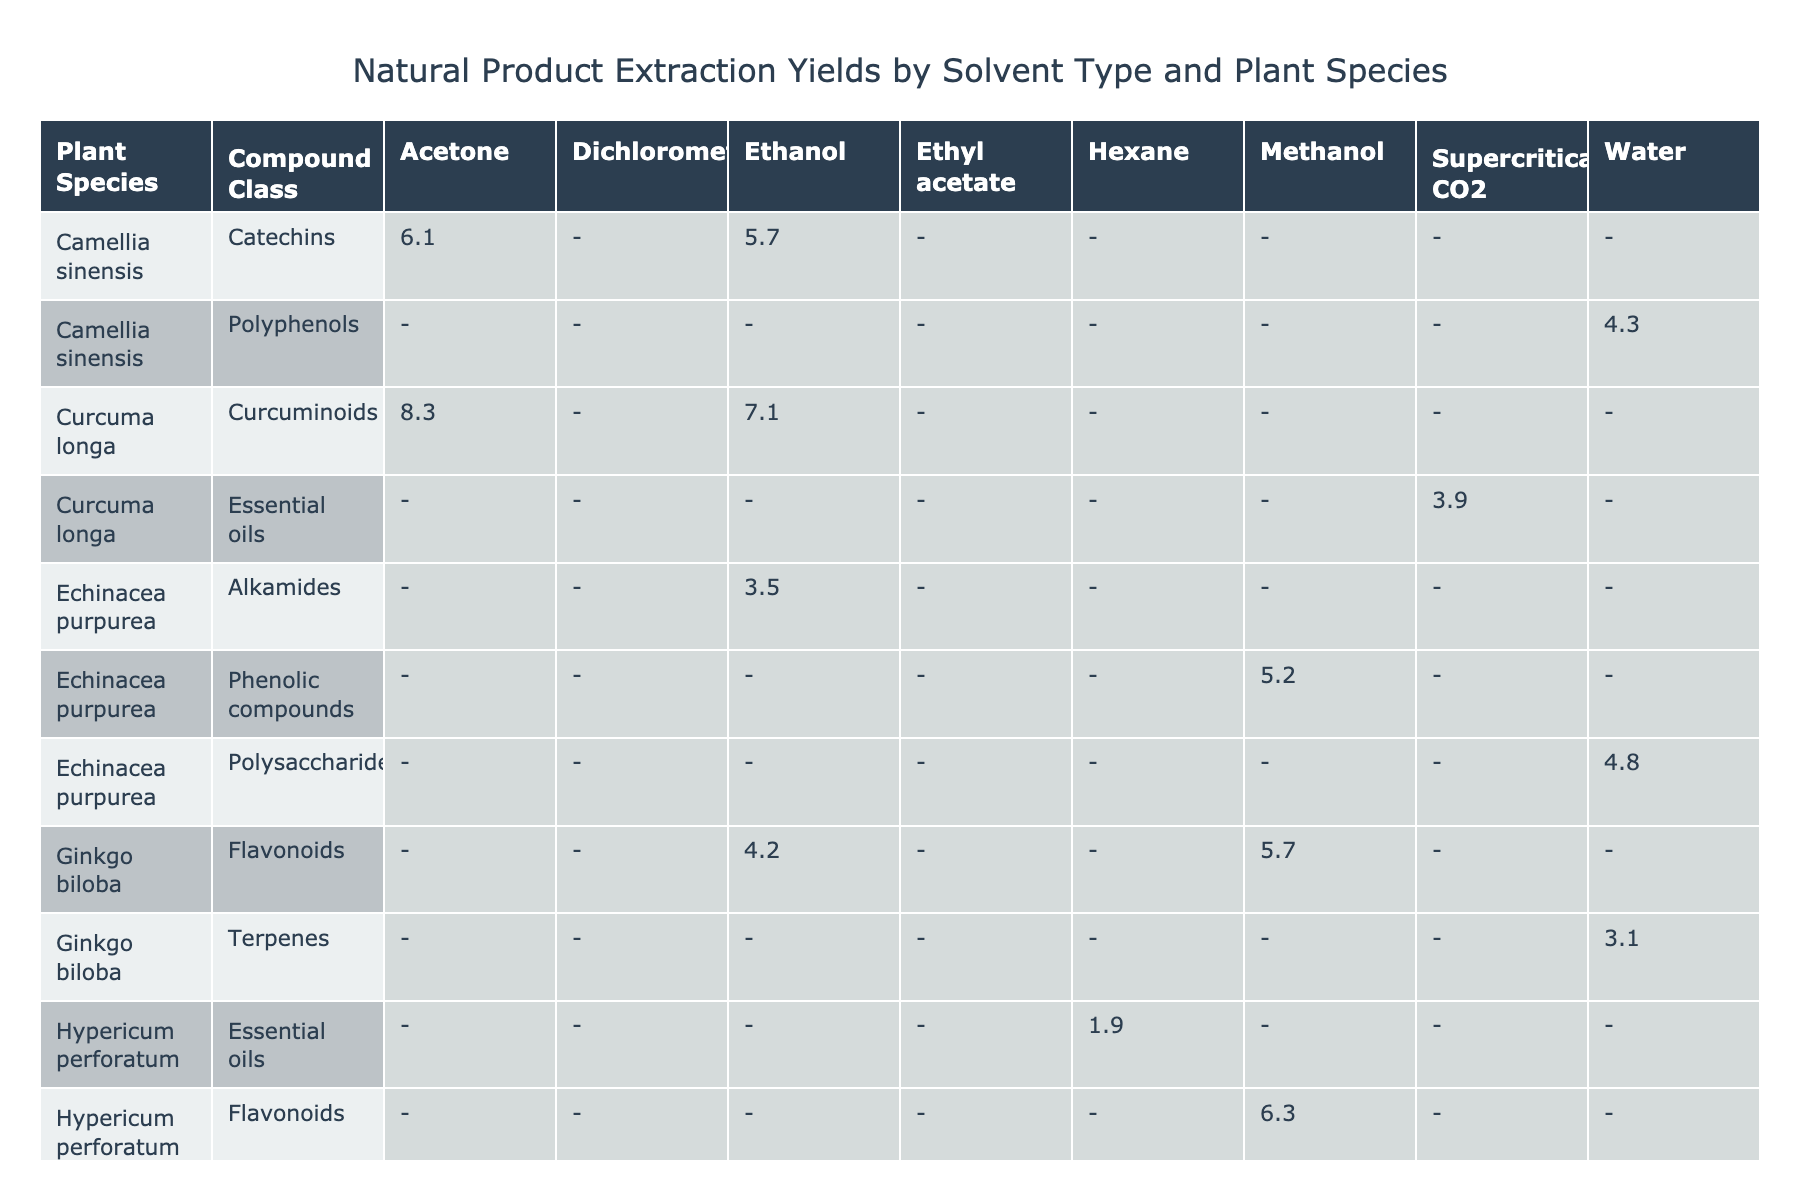What is the highest yield obtained for Ginkgo biloba? In the table, looking at the yield values for Ginkgo biloba, the percentage yields are 4.2, 5.7, and 3.1. The highest of these values is 5.7.
Answer: 5.7 What is the average yield of Curcuma longa when using Ethanol as the solvent? Curcuma longa has one yield value for Ethanol, which is 7.1. Since there's only one value, the average yield is the same: 7.1.
Answer: 7.1 Does Hypericum perforatum have any yields greater than 6.0? Looking through the yield values for Hypericum perforatum, they are 2.8, 6.3, and 1.9. Among these, only 6.3 is greater than 6.0, so the answer is Yes.
Answer: Yes Which plant species has the lowest yield when extracted using Ethyl acetate? The only yield value listed for any plant using Ethyl acetate is 2.8 for Hypericum perforatum. Since it's the only entry, it is the lowest yield.
Answer: 2.8 If we sum the yields for Echinacea purpurea across all solvent types, what is the total? The yields for Echinacea purpurea are 3.5 (Ethanol), 4.8 (Water), and 5.2 (Methanol). Summing these values gives us 3.5 + 4.8 + 5.2 = 13.5.
Answer: 13.5 What extraction method provided the yield of 8.3 for Curcuma longa? The yield of 8.3 for Curcuma longa is associated with the Soxhlet extraction method when using Acetone as the solvent.
Answer: Soxhlet extraction method with Acetone Which solvent produced the highest yield for Panax ginseng? For Panax ginseng, the yield values are 6.8 (Methanol), 5.4 (Water), and 5.9 (Ethanol). The highest yield in this case is 6.8.
Answer: 6.8 Is there any plant species that has a yield under 3.0 using any solvent? The yields for all plants in the table were reviewed, and the lowest yield found is 1.9 for Hypericum perforatum extracted with Hexane. Therefore, the answer is Yes.
Answer: Yes What is the maximum yield extracted using Water among all plant species? The yields using Water are 3.1 (Ginkgo biloba), 4.8 (Echinacea purpurea), 5.4 (Panax ginseng), and 4.3 (Camellia sinensis). The maximum value among these is 5.4 for Panax ginseng.
Answer: 5.4 